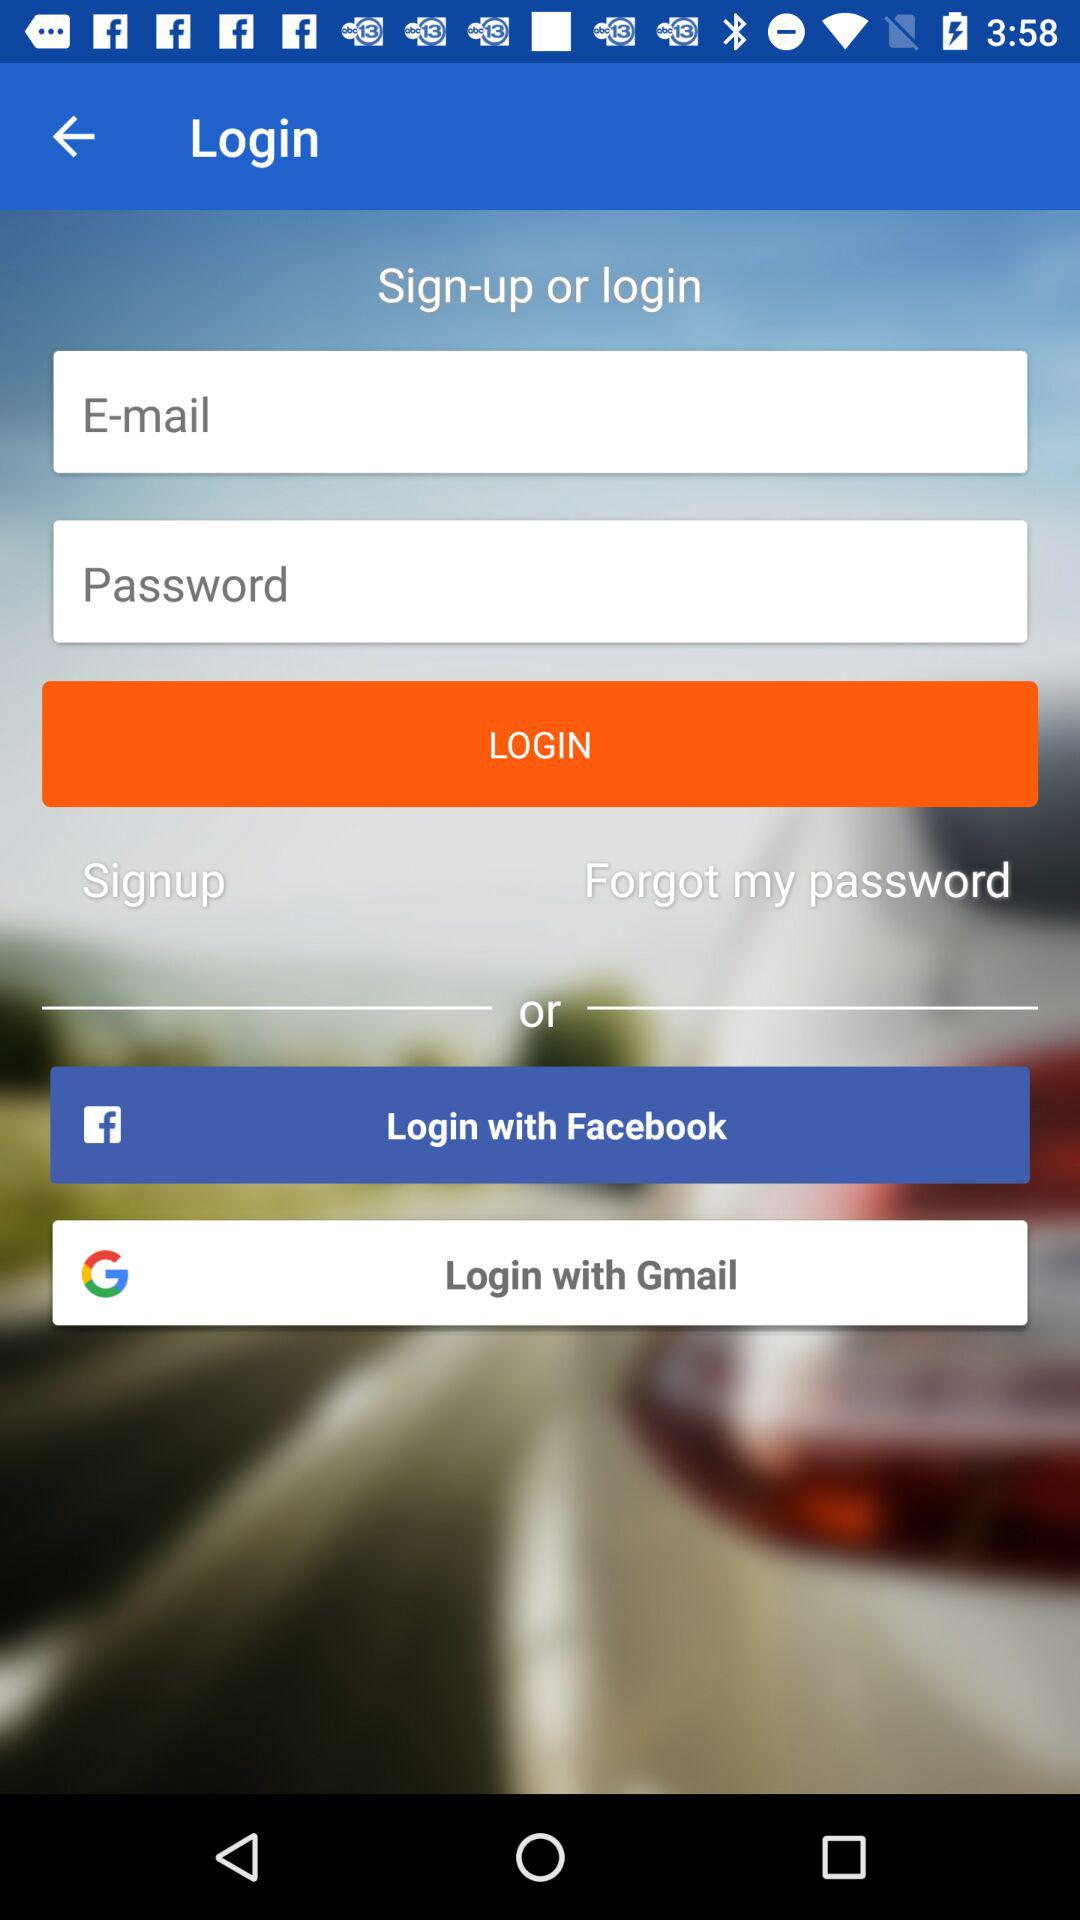Can we reset password?
When the provided information is insufficient, respond with <no answer>. <no answer> 